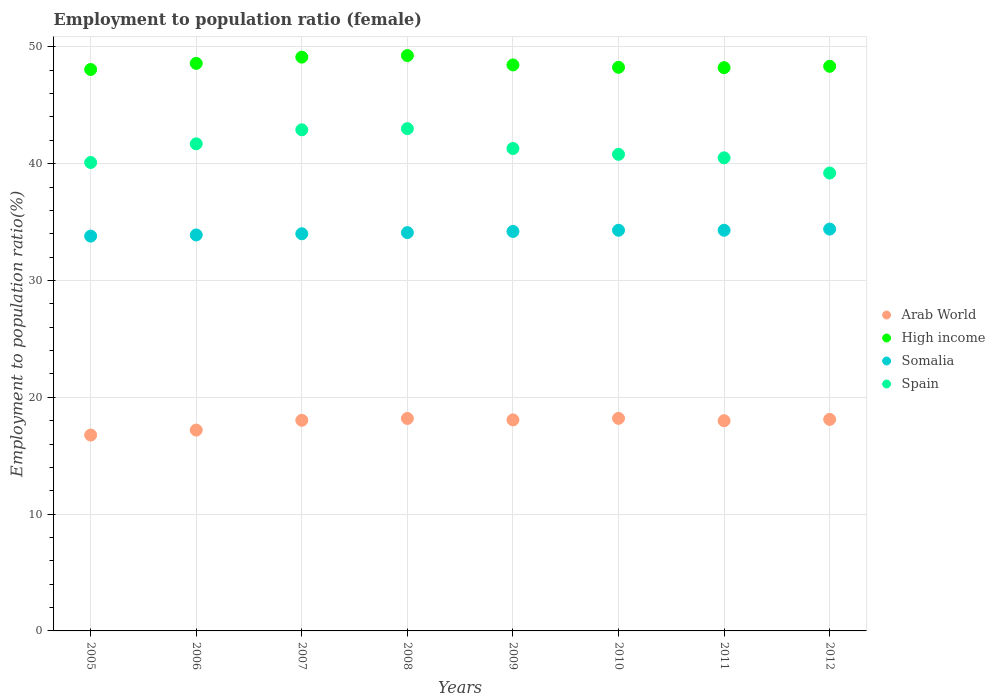How many different coloured dotlines are there?
Ensure brevity in your answer.  4. What is the employment to population ratio in Arab World in 2005?
Your response must be concise. 16.77. Across all years, what is the maximum employment to population ratio in Arab World?
Provide a short and direct response. 18.2. Across all years, what is the minimum employment to population ratio in Spain?
Your response must be concise. 39.2. What is the total employment to population ratio in Arab World in the graph?
Your response must be concise. 142.55. What is the difference between the employment to population ratio in High income in 2007 and that in 2012?
Your answer should be compact. 0.78. What is the difference between the employment to population ratio in High income in 2007 and the employment to population ratio in Arab World in 2008?
Your response must be concise. 30.93. What is the average employment to population ratio in Somalia per year?
Provide a short and direct response. 34.12. In the year 2012, what is the difference between the employment to population ratio in Arab World and employment to population ratio in High income?
Keep it short and to the point. -30.23. In how many years, is the employment to population ratio in Arab World greater than 8 %?
Keep it short and to the point. 8. What is the ratio of the employment to population ratio in Spain in 2006 to that in 2007?
Make the answer very short. 0.97. Is the employment to population ratio in Arab World in 2006 less than that in 2007?
Your answer should be compact. Yes. What is the difference between the highest and the second highest employment to population ratio in High income?
Provide a short and direct response. 0.14. What is the difference between the highest and the lowest employment to population ratio in Arab World?
Give a very brief answer. 1.43. Does the employment to population ratio in Spain monotonically increase over the years?
Keep it short and to the point. No. What is the difference between two consecutive major ticks on the Y-axis?
Your answer should be compact. 10. Are the values on the major ticks of Y-axis written in scientific E-notation?
Ensure brevity in your answer.  No. Does the graph contain any zero values?
Offer a very short reply. No. Does the graph contain grids?
Give a very brief answer. Yes. How are the legend labels stacked?
Provide a succinct answer. Vertical. What is the title of the graph?
Provide a succinct answer. Employment to population ratio (female). Does "Cameroon" appear as one of the legend labels in the graph?
Offer a very short reply. No. What is the label or title of the X-axis?
Your answer should be compact. Years. What is the label or title of the Y-axis?
Ensure brevity in your answer.  Employment to population ratio(%). What is the Employment to population ratio(%) in Arab World in 2005?
Your answer should be compact. 16.77. What is the Employment to population ratio(%) in High income in 2005?
Your answer should be compact. 48.06. What is the Employment to population ratio(%) in Somalia in 2005?
Provide a succinct answer. 33.8. What is the Employment to population ratio(%) of Spain in 2005?
Your answer should be compact. 40.1. What is the Employment to population ratio(%) of Arab World in 2006?
Make the answer very short. 17.19. What is the Employment to population ratio(%) in High income in 2006?
Keep it short and to the point. 48.59. What is the Employment to population ratio(%) of Somalia in 2006?
Provide a succinct answer. 33.9. What is the Employment to population ratio(%) of Spain in 2006?
Offer a terse response. 41.7. What is the Employment to population ratio(%) in Arab World in 2007?
Give a very brief answer. 18.03. What is the Employment to population ratio(%) of High income in 2007?
Your answer should be compact. 49.12. What is the Employment to population ratio(%) of Somalia in 2007?
Provide a short and direct response. 34. What is the Employment to population ratio(%) in Spain in 2007?
Offer a very short reply. 42.9. What is the Employment to population ratio(%) in Arab World in 2008?
Your response must be concise. 18.19. What is the Employment to population ratio(%) of High income in 2008?
Offer a terse response. 49.26. What is the Employment to population ratio(%) in Somalia in 2008?
Offer a terse response. 34.1. What is the Employment to population ratio(%) in Spain in 2008?
Provide a succinct answer. 43. What is the Employment to population ratio(%) of Arab World in 2009?
Provide a short and direct response. 18.07. What is the Employment to population ratio(%) in High income in 2009?
Your response must be concise. 48.46. What is the Employment to population ratio(%) of Somalia in 2009?
Keep it short and to the point. 34.2. What is the Employment to population ratio(%) of Spain in 2009?
Ensure brevity in your answer.  41.3. What is the Employment to population ratio(%) of Arab World in 2010?
Provide a short and direct response. 18.2. What is the Employment to population ratio(%) of High income in 2010?
Make the answer very short. 48.25. What is the Employment to population ratio(%) in Somalia in 2010?
Offer a terse response. 34.3. What is the Employment to population ratio(%) of Spain in 2010?
Offer a very short reply. 40.8. What is the Employment to population ratio(%) of Arab World in 2011?
Make the answer very short. 17.99. What is the Employment to population ratio(%) of High income in 2011?
Offer a very short reply. 48.22. What is the Employment to population ratio(%) in Somalia in 2011?
Your answer should be compact. 34.3. What is the Employment to population ratio(%) of Spain in 2011?
Offer a terse response. 40.5. What is the Employment to population ratio(%) of Arab World in 2012?
Offer a very short reply. 18.11. What is the Employment to population ratio(%) of High income in 2012?
Your answer should be very brief. 48.34. What is the Employment to population ratio(%) of Somalia in 2012?
Ensure brevity in your answer.  34.4. What is the Employment to population ratio(%) of Spain in 2012?
Make the answer very short. 39.2. Across all years, what is the maximum Employment to population ratio(%) of Arab World?
Give a very brief answer. 18.2. Across all years, what is the maximum Employment to population ratio(%) in High income?
Your answer should be very brief. 49.26. Across all years, what is the maximum Employment to population ratio(%) in Somalia?
Your response must be concise. 34.4. Across all years, what is the minimum Employment to population ratio(%) in Arab World?
Your response must be concise. 16.77. Across all years, what is the minimum Employment to population ratio(%) of High income?
Offer a very short reply. 48.06. Across all years, what is the minimum Employment to population ratio(%) of Somalia?
Provide a succinct answer. 33.8. Across all years, what is the minimum Employment to population ratio(%) in Spain?
Make the answer very short. 39.2. What is the total Employment to population ratio(%) of Arab World in the graph?
Offer a very short reply. 142.55. What is the total Employment to population ratio(%) of High income in the graph?
Provide a short and direct response. 388.29. What is the total Employment to population ratio(%) in Somalia in the graph?
Your answer should be compact. 273. What is the total Employment to population ratio(%) in Spain in the graph?
Your answer should be compact. 329.5. What is the difference between the Employment to population ratio(%) in Arab World in 2005 and that in 2006?
Offer a terse response. -0.43. What is the difference between the Employment to population ratio(%) of High income in 2005 and that in 2006?
Provide a succinct answer. -0.52. What is the difference between the Employment to population ratio(%) in Arab World in 2005 and that in 2007?
Your response must be concise. -1.26. What is the difference between the Employment to population ratio(%) in High income in 2005 and that in 2007?
Make the answer very short. -1.06. What is the difference between the Employment to population ratio(%) of Somalia in 2005 and that in 2007?
Ensure brevity in your answer.  -0.2. What is the difference between the Employment to population ratio(%) in Spain in 2005 and that in 2007?
Ensure brevity in your answer.  -2.8. What is the difference between the Employment to population ratio(%) in Arab World in 2005 and that in 2008?
Ensure brevity in your answer.  -1.42. What is the difference between the Employment to population ratio(%) of High income in 2005 and that in 2008?
Provide a short and direct response. -1.19. What is the difference between the Employment to population ratio(%) in Somalia in 2005 and that in 2008?
Offer a very short reply. -0.3. What is the difference between the Employment to population ratio(%) of Arab World in 2005 and that in 2009?
Offer a very short reply. -1.3. What is the difference between the Employment to population ratio(%) of High income in 2005 and that in 2009?
Make the answer very short. -0.39. What is the difference between the Employment to population ratio(%) in Spain in 2005 and that in 2009?
Make the answer very short. -1.2. What is the difference between the Employment to population ratio(%) of Arab World in 2005 and that in 2010?
Your response must be concise. -1.43. What is the difference between the Employment to population ratio(%) of High income in 2005 and that in 2010?
Keep it short and to the point. -0.19. What is the difference between the Employment to population ratio(%) in Arab World in 2005 and that in 2011?
Offer a very short reply. -1.23. What is the difference between the Employment to population ratio(%) in High income in 2005 and that in 2011?
Provide a short and direct response. -0.16. What is the difference between the Employment to population ratio(%) of Somalia in 2005 and that in 2011?
Ensure brevity in your answer.  -0.5. What is the difference between the Employment to population ratio(%) in Spain in 2005 and that in 2011?
Offer a very short reply. -0.4. What is the difference between the Employment to population ratio(%) in Arab World in 2005 and that in 2012?
Ensure brevity in your answer.  -1.34. What is the difference between the Employment to population ratio(%) in High income in 2005 and that in 2012?
Your answer should be compact. -0.27. What is the difference between the Employment to population ratio(%) of Somalia in 2005 and that in 2012?
Offer a terse response. -0.6. What is the difference between the Employment to population ratio(%) of Arab World in 2006 and that in 2007?
Give a very brief answer. -0.84. What is the difference between the Employment to population ratio(%) of High income in 2006 and that in 2007?
Provide a succinct answer. -0.54. What is the difference between the Employment to population ratio(%) in Somalia in 2006 and that in 2007?
Your answer should be compact. -0.1. What is the difference between the Employment to population ratio(%) in Spain in 2006 and that in 2007?
Keep it short and to the point. -1.2. What is the difference between the Employment to population ratio(%) of Arab World in 2006 and that in 2008?
Ensure brevity in your answer.  -1. What is the difference between the Employment to population ratio(%) of High income in 2006 and that in 2008?
Offer a very short reply. -0.67. What is the difference between the Employment to population ratio(%) in Spain in 2006 and that in 2008?
Keep it short and to the point. -1.3. What is the difference between the Employment to population ratio(%) in Arab World in 2006 and that in 2009?
Your answer should be compact. -0.87. What is the difference between the Employment to population ratio(%) in High income in 2006 and that in 2009?
Ensure brevity in your answer.  0.13. What is the difference between the Employment to population ratio(%) of Somalia in 2006 and that in 2009?
Provide a succinct answer. -0.3. What is the difference between the Employment to population ratio(%) in Arab World in 2006 and that in 2010?
Your answer should be very brief. -1. What is the difference between the Employment to population ratio(%) of High income in 2006 and that in 2010?
Offer a very short reply. 0.34. What is the difference between the Employment to population ratio(%) of Somalia in 2006 and that in 2010?
Your answer should be very brief. -0.4. What is the difference between the Employment to population ratio(%) of Arab World in 2006 and that in 2011?
Your answer should be compact. -0.8. What is the difference between the Employment to population ratio(%) in High income in 2006 and that in 2011?
Offer a very short reply. 0.37. What is the difference between the Employment to population ratio(%) in Somalia in 2006 and that in 2011?
Provide a succinct answer. -0.4. What is the difference between the Employment to population ratio(%) of Arab World in 2006 and that in 2012?
Give a very brief answer. -0.91. What is the difference between the Employment to population ratio(%) of High income in 2006 and that in 2012?
Provide a short and direct response. 0.25. What is the difference between the Employment to population ratio(%) of Somalia in 2006 and that in 2012?
Provide a short and direct response. -0.5. What is the difference between the Employment to population ratio(%) in Arab World in 2007 and that in 2008?
Your response must be concise. -0.16. What is the difference between the Employment to population ratio(%) of High income in 2007 and that in 2008?
Provide a succinct answer. -0.14. What is the difference between the Employment to population ratio(%) in Arab World in 2007 and that in 2009?
Offer a very short reply. -0.03. What is the difference between the Employment to population ratio(%) in High income in 2007 and that in 2009?
Give a very brief answer. 0.67. What is the difference between the Employment to population ratio(%) of Spain in 2007 and that in 2009?
Offer a terse response. 1.6. What is the difference between the Employment to population ratio(%) in Arab World in 2007 and that in 2010?
Your response must be concise. -0.17. What is the difference between the Employment to population ratio(%) in High income in 2007 and that in 2010?
Your response must be concise. 0.87. What is the difference between the Employment to population ratio(%) in Somalia in 2007 and that in 2010?
Your response must be concise. -0.3. What is the difference between the Employment to population ratio(%) of Arab World in 2007 and that in 2011?
Your response must be concise. 0.04. What is the difference between the Employment to population ratio(%) of High income in 2007 and that in 2011?
Your answer should be very brief. 0.9. What is the difference between the Employment to population ratio(%) of Somalia in 2007 and that in 2011?
Your answer should be very brief. -0.3. What is the difference between the Employment to population ratio(%) of Spain in 2007 and that in 2011?
Provide a succinct answer. 2.4. What is the difference between the Employment to population ratio(%) in Arab World in 2007 and that in 2012?
Your response must be concise. -0.08. What is the difference between the Employment to population ratio(%) in High income in 2007 and that in 2012?
Make the answer very short. 0.78. What is the difference between the Employment to population ratio(%) of Somalia in 2007 and that in 2012?
Keep it short and to the point. -0.4. What is the difference between the Employment to population ratio(%) in Spain in 2007 and that in 2012?
Provide a short and direct response. 3.7. What is the difference between the Employment to population ratio(%) in Arab World in 2008 and that in 2009?
Offer a very short reply. 0.12. What is the difference between the Employment to population ratio(%) of High income in 2008 and that in 2009?
Ensure brevity in your answer.  0.8. What is the difference between the Employment to population ratio(%) in Somalia in 2008 and that in 2009?
Give a very brief answer. -0.1. What is the difference between the Employment to population ratio(%) in Spain in 2008 and that in 2009?
Give a very brief answer. 1.7. What is the difference between the Employment to population ratio(%) of Arab World in 2008 and that in 2010?
Your response must be concise. -0.01. What is the difference between the Employment to population ratio(%) in Spain in 2008 and that in 2010?
Make the answer very short. 2.2. What is the difference between the Employment to population ratio(%) in Arab World in 2008 and that in 2011?
Offer a very short reply. 0.2. What is the difference between the Employment to population ratio(%) of High income in 2008 and that in 2011?
Your response must be concise. 1.04. What is the difference between the Employment to population ratio(%) of Arab World in 2008 and that in 2012?
Offer a very short reply. 0.08. What is the difference between the Employment to population ratio(%) of High income in 2008 and that in 2012?
Make the answer very short. 0.92. What is the difference between the Employment to population ratio(%) of Arab World in 2009 and that in 2010?
Ensure brevity in your answer.  -0.13. What is the difference between the Employment to population ratio(%) in High income in 2009 and that in 2010?
Provide a succinct answer. 0.2. What is the difference between the Employment to population ratio(%) in Spain in 2009 and that in 2010?
Your response must be concise. 0.5. What is the difference between the Employment to population ratio(%) of Arab World in 2009 and that in 2011?
Provide a short and direct response. 0.07. What is the difference between the Employment to population ratio(%) in High income in 2009 and that in 2011?
Your answer should be compact. 0.23. What is the difference between the Employment to population ratio(%) of Spain in 2009 and that in 2011?
Keep it short and to the point. 0.8. What is the difference between the Employment to population ratio(%) of Arab World in 2009 and that in 2012?
Offer a very short reply. -0.04. What is the difference between the Employment to population ratio(%) of High income in 2009 and that in 2012?
Provide a short and direct response. 0.12. What is the difference between the Employment to population ratio(%) in Somalia in 2009 and that in 2012?
Provide a succinct answer. -0.2. What is the difference between the Employment to population ratio(%) of Spain in 2009 and that in 2012?
Ensure brevity in your answer.  2.1. What is the difference between the Employment to population ratio(%) of Arab World in 2010 and that in 2011?
Provide a short and direct response. 0.2. What is the difference between the Employment to population ratio(%) of High income in 2010 and that in 2011?
Provide a short and direct response. 0.03. What is the difference between the Employment to population ratio(%) in Spain in 2010 and that in 2011?
Offer a terse response. 0.3. What is the difference between the Employment to population ratio(%) of Arab World in 2010 and that in 2012?
Your answer should be compact. 0.09. What is the difference between the Employment to population ratio(%) in High income in 2010 and that in 2012?
Ensure brevity in your answer.  -0.09. What is the difference between the Employment to population ratio(%) in Arab World in 2011 and that in 2012?
Your response must be concise. -0.11. What is the difference between the Employment to population ratio(%) in High income in 2011 and that in 2012?
Provide a short and direct response. -0.12. What is the difference between the Employment to population ratio(%) of Somalia in 2011 and that in 2012?
Give a very brief answer. -0.1. What is the difference between the Employment to population ratio(%) in Arab World in 2005 and the Employment to population ratio(%) in High income in 2006?
Give a very brief answer. -31.82. What is the difference between the Employment to population ratio(%) of Arab World in 2005 and the Employment to population ratio(%) of Somalia in 2006?
Offer a very short reply. -17.13. What is the difference between the Employment to population ratio(%) of Arab World in 2005 and the Employment to population ratio(%) of Spain in 2006?
Provide a short and direct response. -24.93. What is the difference between the Employment to population ratio(%) in High income in 2005 and the Employment to population ratio(%) in Somalia in 2006?
Give a very brief answer. 14.16. What is the difference between the Employment to population ratio(%) of High income in 2005 and the Employment to population ratio(%) of Spain in 2006?
Your answer should be compact. 6.36. What is the difference between the Employment to population ratio(%) in Somalia in 2005 and the Employment to population ratio(%) in Spain in 2006?
Your answer should be compact. -7.9. What is the difference between the Employment to population ratio(%) in Arab World in 2005 and the Employment to population ratio(%) in High income in 2007?
Your answer should be very brief. -32.35. What is the difference between the Employment to population ratio(%) of Arab World in 2005 and the Employment to population ratio(%) of Somalia in 2007?
Offer a terse response. -17.23. What is the difference between the Employment to population ratio(%) of Arab World in 2005 and the Employment to population ratio(%) of Spain in 2007?
Provide a succinct answer. -26.13. What is the difference between the Employment to population ratio(%) of High income in 2005 and the Employment to population ratio(%) of Somalia in 2007?
Provide a short and direct response. 14.06. What is the difference between the Employment to population ratio(%) of High income in 2005 and the Employment to population ratio(%) of Spain in 2007?
Ensure brevity in your answer.  5.16. What is the difference between the Employment to population ratio(%) in Somalia in 2005 and the Employment to population ratio(%) in Spain in 2007?
Your response must be concise. -9.1. What is the difference between the Employment to population ratio(%) in Arab World in 2005 and the Employment to population ratio(%) in High income in 2008?
Provide a short and direct response. -32.49. What is the difference between the Employment to population ratio(%) in Arab World in 2005 and the Employment to population ratio(%) in Somalia in 2008?
Keep it short and to the point. -17.33. What is the difference between the Employment to population ratio(%) in Arab World in 2005 and the Employment to population ratio(%) in Spain in 2008?
Your answer should be compact. -26.23. What is the difference between the Employment to population ratio(%) in High income in 2005 and the Employment to population ratio(%) in Somalia in 2008?
Give a very brief answer. 13.96. What is the difference between the Employment to population ratio(%) of High income in 2005 and the Employment to population ratio(%) of Spain in 2008?
Offer a terse response. 5.06. What is the difference between the Employment to population ratio(%) in Arab World in 2005 and the Employment to population ratio(%) in High income in 2009?
Provide a short and direct response. -31.69. What is the difference between the Employment to population ratio(%) in Arab World in 2005 and the Employment to population ratio(%) in Somalia in 2009?
Give a very brief answer. -17.43. What is the difference between the Employment to population ratio(%) in Arab World in 2005 and the Employment to population ratio(%) in Spain in 2009?
Ensure brevity in your answer.  -24.53. What is the difference between the Employment to population ratio(%) in High income in 2005 and the Employment to population ratio(%) in Somalia in 2009?
Provide a succinct answer. 13.86. What is the difference between the Employment to population ratio(%) in High income in 2005 and the Employment to population ratio(%) in Spain in 2009?
Your answer should be very brief. 6.76. What is the difference between the Employment to population ratio(%) in Somalia in 2005 and the Employment to population ratio(%) in Spain in 2009?
Offer a terse response. -7.5. What is the difference between the Employment to population ratio(%) in Arab World in 2005 and the Employment to population ratio(%) in High income in 2010?
Give a very brief answer. -31.48. What is the difference between the Employment to population ratio(%) of Arab World in 2005 and the Employment to population ratio(%) of Somalia in 2010?
Offer a terse response. -17.53. What is the difference between the Employment to population ratio(%) in Arab World in 2005 and the Employment to population ratio(%) in Spain in 2010?
Your answer should be compact. -24.03. What is the difference between the Employment to population ratio(%) of High income in 2005 and the Employment to population ratio(%) of Somalia in 2010?
Provide a succinct answer. 13.76. What is the difference between the Employment to population ratio(%) in High income in 2005 and the Employment to population ratio(%) in Spain in 2010?
Keep it short and to the point. 7.26. What is the difference between the Employment to population ratio(%) in Arab World in 2005 and the Employment to population ratio(%) in High income in 2011?
Provide a short and direct response. -31.45. What is the difference between the Employment to population ratio(%) of Arab World in 2005 and the Employment to population ratio(%) of Somalia in 2011?
Provide a succinct answer. -17.53. What is the difference between the Employment to population ratio(%) of Arab World in 2005 and the Employment to population ratio(%) of Spain in 2011?
Keep it short and to the point. -23.73. What is the difference between the Employment to population ratio(%) of High income in 2005 and the Employment to population ratio(%) of Somalia in 2011?
Your answer should be compact. 13.76. What is the difference between the Employment to population ratio(%) in High income in 2005 and the Employment to population ratio(%) in Spain in 2011?
Provide a succinct answer. 7.56. What is the difference between the Employment to population ratio(%) of Somalia in 2005 and the Employment to population ratio(%) of Spain in 2011?
Provide a short and direct response. -6.7. What is the difference between the Employment to population ratio(%) in Arab World in 2005 and the Employment to population ratio(%) in High income in 2012?
Offer a very short reply. -31.57. What is the difference between the Employment to population ratio(%) in Arab World in 2005 and the Employment to population ratio(%) in Somalia in 2012?
Offer a very short reply. -17.63. What is the difference between the Employment to population ratio(%) in Arab World in 2005 and the Employment to population ratio(%) in Spain in 2012?
Provide a short and direct response. -22.43. What is the difference between the Employment to population ratio(%) of High income in 2005 and the Employment to population ratio(%) of Somalia in 2012?
Give a very brief answer. 13.66. What is the difference between the Employment to population ratio(%) in High income in 2005 and the Employment to population ratio(%) in Spain in 2012?
Give a very brief answer. 8.86. What is the difference between the Employment to population ratio(%) of Somalia in 2005 and the Employment to population ratio(%) of Spain in 2012?
Your response must be concise. -5.4. What is the difference between the Employment to population ratio(%) in Arab World in 2006 and the Employment to population ratio(%) in High income in 2007?
Offer a very short reply. -31.93. What is the difference between the Employment to population ratio(%) in Arab World in 2006 and the Employment to population ratio(%) in Somalia in 2007?
Offer a very short reply. -16.81. What is the difference between the Employment to population ratio(%) in Arab World in 2006 and the Employment to population ratio(%) in Spain in 2007?
Your answer should be compact. -25.71. What is the difference between the Employment to population ratio(%) in High income in 2006 and the Employment to population ratio(%) in Somalia in 2007?
Ensure brevity in your answer.  14.59. What is the difference between the Employment to population ratio(%) in High income in 2006 and the Employment to population ratio(%) in Spain in 2007?
Offer a terse response. 5.69. What is the difference between the Employment to population ratio(%) in Somalia in 2006 and the Employment to population ratio(%) in Spain in 2007?
Provide a short and direct response. -9. What is the difference between the Employment to population ratio(%) in Arab World in 2006 and the Employment to population ratio(%) in High income in 2008?
Ensure brevity in your answer.  -32.06. What is the difference between the Employment to population ratio(%) in Arab World in 2006 and the Employment to population ratio(%) in Somalia in 2008?
Keep it short and to the point. -16.91. What is the difference between the Employment to population ratio(%) of Arab World in 2006 and the Employment to population ratio(%) of Spain in 2008?
Offer a very short reply. -25.81. What is the difference between the Employment to population ratio(%) in High income in 2006 and the Employment to population ratio(%) in Somalia in 2008?
Offer a very short reply. 14.49. What is the difference between the Employment to population ratio(%) in High income in 2006 and the Employment to population ratio(%) in Spain in 2008?
Keep it short and to the point. 5.59. What is the difference between the Employment to population ratio(%) of Arab World in 2006 and the Employment to population ratio(%) of High income in 2009?
Your answer should be compact. -31.26. What is the difference between the Employment to population ratio(%) of Arab World in 2006 and the Employment to population ratio(%) of Somalia in 2009?
Offer a terse response. -17.01. What is the difference between the Employment to population ratio(%) in Arab World in 2006 and the Employment to population ratio(%) in Spain in 2009?
Ensure brevity in your answer.  -24.11. What is the difference between the Employment to population ratio(%) in High income in 2006 and the Employment to population ratio(%) in Somalia in 2009?
Offer a terse response. 14.39. What is the difference between the Employment to population ratio(%) of High income in 2006 and the Employment to population ratio(%) of Spain in 2009?
Your response must be concise. 7.29. What is the difference between the Employment to population ratio(%) of Somalia in 2006 and the Employment to population ratio(%) of Spain in 2009?
Offer a very short reply. -7.4. What is the difference between the Employment to population ratio(%) of Arab World in 2006 and the Employment to population ratio(%) of High income in 2010?
Your answer should be compact. -31.06. What is the difference between the Employment to population ratio(%) in Arab World in 2006 and the Employment to population ratio(%) in Somalia in 2010?
Keep it short and to the point. -17.11. What is the difference between the Employment to population ratio(%) in Arab World in 2006 and the Employment to population ratio(%) in Spain in 2010?
Ensure brevity in your answer.  -23.61. What is the difference between the Employment to population ratio(%) of High income in 2006 and the Employment to population ratio(%) of Somalia in 2010?
Give a very brief answer. 14.29. What is the difference between the Employment to population ratio(%) in High income in 2006 and the Employment to population ratio(%) in Spain in 2010?
Offer a very short reply. 7.79. What is the difference between the Employment to population ratio(%) of Somalia in 2006 and the Employment to population ratio(%) of Spain in 2010?
Ensure brevity in your answer.  -6.9. What is the difference between the Employment to population ratio(%) in Arab World in 2006 and the Employment to population ratio(%) in High income in 2011?
Your answer should be very brief. -31.03. What is the difference between the Employment to population ratio(%) in Arab World in 2006 and the Employment to population ratio(%) in Somalia in 2011?
Provide a short and direct response. -17.11. What is the difference between the Employment to population ratio(%) in Arab World in 2006 and the Employment to population ratio(%) in Spain in 2011?
Provide a succinct answer. -23.31. What is the difference between the Employment to population ratio(%) of High income in 2006 and the Employment to population ratio(%) of Somalia in 2011?
Give a very brief answer. 14.29. What is the difference between the Employment to population ratio(%) of High income in 2006 and the Employment to population ratio(%) of Spain in 2011?
Provide a succinct answer. 8.09. What is the difference between the Employment to population ratio(%) of Somalia in 2006 and the Employment to population ratio(%) of Spain in 2011?
Give a very brief answer. -6.6. What is the difference between the Employment to population ratio(%) of Arab World in 2006 and the Employment to population ratio(%) of High income in 2012?
Ensure brevity in your answer.  -31.14. What is the difference between the Employment to population ratio(%) of Arab World in 2006 and the Employment to population ratio(%) of Somalia in 2012?
Give a very brief answer. -17.21. What is the difference between the Employment to population ratio(%) of Arab World in 2006 and the Employment to population ratio(%) of Spain in 2012?
Ensure brevity in your answer.  -22.01. What is the difference between the Employment to population ratio(%) in High income in 2006 and the Employment to population ratio(%) in Somalia in 2012?
Keep it short and to the point. 14.19. What is the difference between the Employment to population ratio(%) of High income in 2006 and the Employment to population ratio(%) of Spain in 2012?
Make the answer very short. 9.39. What is the difference between the Employment to population ratio(%) of Somalia in 2006 and the Employment to population ratio(%) of Spain in 2012?
Offer a terse response. -5.3. What is the difference between the Employment to population ratio(%) of Arab World in 2007 and the Employment to population ratio(%) of High income in 2008?
Provide a succinct answer. -31.23. What is the difference between the Employment to population ratio(%) of Arab World in 2007 and the Employment to population ratio(%) of Somalia in 2008?
Offer a very short reply. -16.07. What is the difference between the Employment to population ratio(%) of Arab World in 2007 and the Employment to population ratio(%) of Spain in 2008?
Provide a succinct answer. -24.97. What is the difference between the Employment to population ratio(%) of High income in 2007 and the Employment to population ratio(%) of Somalia in 2008?
Keep it short and to the point. 15.02. What is the difference between the Employment to population ratio(%) in High income in 2007 and the Employment to population ratio(%) in Spain in 2008?
Make the answer very short. 6.12. What is the difference between the Employment to population ratio(%) in Arab World in 2007 and the Employment to population ratio(%) in High income in 2009?
Your response must be concise. -30.42. What is the difference between the Employment to population ratio(%) of Arab World in 2007 and the Employment to population ratio(%) of Somalia in 2009?
Your answer should be compact. -16.17. What is the difference between the Employment to population ratio(%) in Arab World in 2007 and the Employment to population ratio(%) in Spain in 2009?
Your response must be concise. -23.27. What is the difference between the Employment to population ratio(%) of High income in 2007 and the Employment to population ratio(%) of Somalia in 2009?
Your answer should be very brief. 14.92. What is the difference between the Employment to population ratio(%) of High income in 2007 and the Employment to population ratio(%) of Spain in 2009?
Your response must be concise. 7.82. What is the difference between the Employment to population ratio(%) in Arab World in 2007 and the Employment to population ratio(%) in High income in 2010?
Ensure brevity in your answer.  -30.22. What is the difference between the Employment to population ratio(%) in Arab World in 2007 and the Employment to population ratio(%) in Somalia in 2010?
Your answer should be compact. -16.27. What is the difference between the Employment to population ratio(%) in Arab World in 2007 and the Employment to population ratio(%) in Spain in 2010?
Your response must be concise. -22.77. What is the difference between the Employment to population ratio(%) in High income in 2007 and the Employment to population ratio(%) in Somalia in 2010?
Your response must be concise. 14.82. What is the difference between the Employment to population ratio(%) in High income in 2007 and the Employment to population ratio(%) in Spain in 2010?
Give a very brief answer. 8.32. What is the difference between the Employment to population ratio(%) of Arab World in 2007 and the Employment to population ratio(%) of High income in 2011?
Your response must be concise. -30.19. What is the difference between the Employment to population ratio(%) of Arab World in 2007 and the Employment to population ratio(%) of Somalia in 2011?
Give a very brief answer. -16.27. What is the difference between the Employment to population ratio(%) of Arab World in 2007 and the Employment to population ratio(%) of Spain in 2011?
Provide a succinct answer. -22.47. What is the difference between the Employment to population ratio(%) of High income in 2007 and the Employment to population ratio(%) of Somalia in 2011?
Offer a very short reply. 14.82. What is the difference between the Employment to population ratio(%) of High income in 2007 and the Employment to population ratio(%) of Spain in 2011?
Offer a terse response. 8.62. What is the difference between the Employment to population ratio(%) of Arab World in 2007 and the Employment to population ratio(%) of High income in 2012?
Provide a succinct answer. -30.31. What is the difference between the Employment to population ratio(%) of Arab World in 2007 and the Employment to population ratio(%) of Somalia in 2012?
Offer a very short reply. -16.37. What is the difference between the Employment to population ratio(%) in Arab World in 2007 and the Employment to population ratio(%) in Spain in 2012?
Ensure brevity in your answer.  -21.17. What is the difference between the Employment to population ratio(%) in High income in 2007 and the Employment to population ratio(%) in Somalia in 2012?
Make the answer very short. 14.72. What is the difference between the Employment to population ratio(%) in High income in 2007 and the Employment to population ratio(%) in Spain in 2012?
Keep it short and to the point. 9.92. What is the difference between the Employment to population ratio(%) in Somalia in 2007 and the Employment to population ratio(%) in Spain in 2012?
Your answer should be compact. -5.2. What is the difference between the Employment to population ratio(%) in Arab World in 2008 and the Employment to population ratio(%) in High income in 2009?
Your answer should be very brief. -30.27. What is the difference between the Employment to population ratio(%) of Arab World in 2008 and the Employment to population ratio(%) of Somalia in 2009?
Provide a succinct answer. -16.01. What is the difference between the Employment to population ratio(%) in Arab World in 2008 and the Employment to population ratio(%) in Spain in 2009?
Your answer should be very brief. -23.11. What is the difference between the Employment to population ratio(%) in High income in 2008 and the Employment to population ratio(%) in Somalia in 2009?
Offer a very short reply. 15.06. What is the difference between the Employment to population ratio(%) in High income in 2008 and the Employment to population ratio(%) in Spain in 2009?
Give a very brief answer. 7.96. What is the difference between the Employment to population ratio(%) in Somalia in 2008 and the Employment to population ratio(%) in Spain in 2009?
Ensure brevity in your answer.  -7.2. What is the difference between the Employment to population ratio(%) of Arab World in 2008 and the Employment to population ratio(%) of High income in 2010?
Offer a terse response. -30.06. What is the difference between the Employment to population ratio(%) in Arab World in 2008 and the Employment to population ratio(%) in Somalia in 2010?
Your answer should be very brief. -16.11. What is the difference between the Employment to population ratio(%) of Arab World in 2008 and the Employment to population ratio(%) of Spain in 2010?
Your answer should be very brief. -22.61. What is the difference between the Employment to population ratio(%) in High income in 2008 and the Employment to population ratio(%) in Somalia in 2010?
Keep it short and to the point. 14.96. What is the difference between the Employment to population ratio(%) of High income in 2008 and the Employment to population ratio(%) of Spain in 2010?
Ensure brevity in your answer.  8.46. What is the difference between the Employment to population ratio(%) of Somalia in 2008 and the Employment to population ratio(%) of Spain in 2010?
Give a very brief answer. -6.7. What is the difference between the Employment to population ratio(%) of Arab World in 2008 and the Employment to population ratio(%) of High income in 2011?
Offer a terse response. -30.03. What is the difference between the Employment to population ratio(%) in Arab World in 2008 and the Employment to population ratio(%) in Somalia in 2011?
Provide a short and direct response. -16.11. What is the difference between the Employment to population ratio(%) of Arab World in 2008 and the Employment to population ratio(%) of Spain in 2011?
Make the answer very short. -22.31. What is the difference between the Employment to population ratio(%) of High income in 2008 and the Employment to population ratio(%) of Somalia in 2011?
Offer a terse response. 14.96. What is the difference between the Employment to population ratio(%) in High income in 2008 and the Employment to population ratio(%) in Spain in 2011?
Your answer should be compact. 8.76. What is the difference between the Employment to population ratio(%) of Arab World in 2008 and the Employment to population ratio(%) of High income in 2012?
Provide a short and direct response. -30.15. What is the difference between the Employment to population ratio(%) of Arab World in 2008 and the Employment to population ratio(%) of Somalia in 2012?
Your answer should be compact. -16.21. What is the difference between the Employment to population ratio(%) of Arab World in 2008 and the Employment to population ratio(%) of Spain in 2012?
Offer a very short reply. -21.01. What is the difference between the Employment to population ratio(%) of High income in 2008 and the Employment to population ratio(%) of Somalia in 2012?
Your response must be concise. 14.86. What is the difference between the Employment to population ratio(%) of High income in 2008 and the Employment to population ratio(%) of Spain in 2012?
Provide a succinct answer. 10.06. What is the difference between the Employment to population ratio(%) of Somalia in 2008 and the Employment to population ratio(%) of Spain in 2012?
Your answer should be compact. -5.1. What is the difference between the Employment to population ratio(%) in Arab World in 2009 and the Employment to population ratio(%) in High income in 2010?
Offer a terse response. -30.18. What is the difference between the Employment to population ratio(%) of Arab World in 2009 and the Employment to population ratio(%) of Somalia in 2010?
Provide a succinct answer. -16.23. What is the difference between the Employment to population ratio(%) in Arab World in 2009 and the Employment to population ratio(%) in Spain in 2010?
Offer a terse response. -22.73. What is the difference between the Employment to population ratio(%) of High income in 2009 and the Employment to population ratio(%) of Somalia in 2010?
Provide a short and direct response. 14.16. What is the difference between the Employment to population ratio(%) of High income in 2009 and the Employment to population ratio(%) of Spain in 2010?
Ensure brevity in your answer.  7.66. What is the difference between the Employment to population ratio(%) in Somalia in 2009 and the Employment to population ratio(%) in Spain in 2010?
Ensure brevity in your answer.  -6.6. What is the difference between the Employment to population ratio(%) of Arab World in 2009 and the Employment to population ratio(%) of High income in 2011?
Offer a terse response. -30.16. What is the difference between the Employment to population ratio(%) of Arab World in 2009 and the Employment to population ratio(%) of Somalia in 2011?
Offer a very short reply. -16.23. What is the difference between the Employment to population ratio(%) in Arab World in 2009 and the Employment to population ratio(%) in Spain in 2011?
Keep it short and to the point. -22.43. What is the difference between the Employment to population ratio(%) in High income in 2009 and the Employment to population ratio(%) in Somalia in 2011?
Provide a short and direct response. 14.16. What is the difference between the Employment to population ratio(%) of High income in 2009 and the Employment to population ratio(%) of Spain in 2011?
Offer a very short reply. 7.96. What is the difference between the Employment to population ratio(%) of Somalia in 2009 and the Employment to population ratio(%) of Spain in 2011?
Offer a terse response. -6.3. What is the difference between the Employment to population ratio(%) of Arab World in 2009 and the Employment to population ratio(%) of High income in 2012?
Your answer should be compact. -30.27. What is the difference between the Employment to population ratio(%) of Arab World in 2009 and the Employment to population ratio(%) of Somalia in 2012?
Keep it short and to the point. -16.33. What is the difference between the Employment to population ratio(%) of Arab World in 2009 and the Employment to population ratio(%) of Spain in 2012?
Provide a short and direct response. -21.13. What is the difference between the Employment to population ratio(%) in High income in 2009 and the Employment to population ratio(%) in Somalia in 2012?
Offer a terse response. 14.06. What is the difference between the Employment to population ratio(%) in High income in 2009 and the Employment to population ratio(%) in Spain in 2012?
Ensure brevity in your answer.  9.26. What is the difference between the Employment to population ratio(%) of Somalia in 2009 and the Employment to population ratio(%) of Spain in 2012?
Ensure brevity in your answer.  -5. What is the difference between the Employment to population ratio(%) of Arab World in 2010 and the Employment to population ratio(%) of High income in 2011?
Offer a very short reply. -30.02. What is the difference between the Employment to population ratio(%) in Arab World in 2010 and the Employment to population ratio(%) in Somalia in 2011?
Offer a very short reply. -16.1. What is the difference between the Employment to population ratio(%) of Arab World in 2010 and the Employment to population ratio(%) of Spain in 2011?
Offer a terse response. -22.3. What is the difference between the Employment to population ratio(%) in High income in 2010 and the Employment to population ratio(%) in Somalia in 2011?
Keep it short and to the point. 13.95. What is the difference between the Employment to population ratio(%) in High income in 2010 and the Employment to population ratio(%) in Spain in 2011?
Provide a succinct answer. 7.75. What is the difference between the Employment to population ratio(%) of Somalia in 2010 and the Employment to population ratio(%) of Spain in 2011?
Your answer should be very brief. -6.2. What is the difference between the Employment to population ratio(%) in Arab World in 2010 and the Employment to population ratio(%) in High income in 2012?
Your response must be concise. -30.14. What is the difference between the Employment to population ratio(%) of Arab World in 2010 and the Employment to population ratio(%) of Somalia in 2012?
Give a very brief answer. -16.2. What is the difference between the Employment to population ratio(%) in Arab World in 2010 and the Employment to population ratio(%) in Spain in 2012?
Provide a succinct answer. -21. What is the difference between the Employment to population ratio(%) of High income in 2010 and the Employment to population ratio(%) of Somalia in 2012?
Offer a terse response. 13.85. What is the difference between the Employment to population ratio(%) in High income in 2010 and the Employment to population ratio(%) in Spain in 2012?
Your response must be concise. 9.05. What is the difference between the Employment to population ratio(%) in Arab World in 2011 and the Employment to population ratio(%) in High income in 2012?
Offer a terse response. -30.34. What is the difference between the Employment to population ratio(%) of Arab World in 2011 and the Employment to population ratio(%) of Somalia in 2012?
Provide a short and direct response. -16.41. What is the difference between the Employment to population ratio(%) of Arab World in 2011 and the Employment to population ratio(%) of Spain in 2012?
Make the answer very short. -21.21. What is the difference between the Employment to population ratio(%) in High income in 2011 and the Employment to population ratio(%) in Somalia in 2012?
Provide a succinct answer. 13.82. What is the difference between the Employment to population ratio(%) in High income in 2011 and the Employment to population ratio(%) in Spain in 2012?
Provide a short and direct response. 9.02. What is the difference between the Employment to population ratio(%) of Somalia in 2011 and the Employment to population ratio(%) of Spain in 2012?
Your response must be concise. -4.9. What is the average Employment to population ratio(%) of Arab World per year?
Make the answer very short. 17.82. What is the average Employment to population ratio(%) in High income per year?
Give a very brief answer. 48.54. What is the average Employment to population ratio(%) in Somalia per year?
Offer a very short reply. 34.12. What is the average Employment to population ratio(%) in Spain per year?
Ensure brevity in your answer.  41.19. In the year 2005, what is the difference between the Employment to population ratio(%) in Arab World and Employment to population ratio(%) in High income?
Make the answer very short. -31.3. In the year 2005, what is the difference between the Employment to population ratio(%) of Arab World and Employment to population ratio(%) of Somalia?
Offer a terse response. -17.03. In the year 2005, what is the difference between the Employment to population ratio(%) of Arab World and Employment to population ratio(%) of Spain?
Ensure brevity in your answer.  -23.33. In the year 2005, what is the difference between the Employment to population ratio(%) of High income and Employment to population ratio(%) of Somalia?
Ensure brevity in your answer.  14.26. In the year 2005, what is the difference between the Employment to population ratio(%) of High income and Employment to population ratio(%) of Spain?
Your response must be concise. 7.96. In the year 2006, what is the difference between the Employment to population ratio(%) of Arab World and Employment to population ratio(%) of High income?
Your answer should be very brief. -31.39. In the year 2006, what is the difference between the Employment to population ratio(%) in Arab World and Employment to population ratio(%) in Somalia?
Ensure brevity in your answer.  -16.71. In the year 2006, what is the difference between the Employment to population ratio(%) in Arab World and Employment to population ratio(%) in Spain?
Make the answer very short. -24.51. In the year 2006, what is the difference between the Employment to population ratio(%) in High income and Employment to population ratio(%) in Somalia?
Offer a very short reply. 14.69. In the year 2006, what is the difference between the Employment to population ratio(%) of High income and Employment to population ratio(%) of Spain?
Give a very brief answer. 6.89. In the year 2006, what is the difference between the Employment to population ratio(%) of Somalia and Employment to population ratio(%) of Spain?
Offer a very short reply. -7.8. In the year 2007, what is the difference between the Employment to population ratio(%) in Arab World and Employment to population ratio(%) in High income?
Your answer should be very brief. -31.09. In the year 2007, what is the difference between the Employment to population ratio(%) of Arab World and Employment to population ratio(%) of Somalia?
Provide a succinct answer. -15.97. In the year 2007, what is the difference between the Employment to population ratio(%) of Arab World and Employment to population ratio(%) of Spain?
Give a very brief answer. -24.87. In the year 2007, what is the difference between the Employment to population ratio(%) of High income and Employment to population ratio(%) of Somalia?
Your answer should be very brief. 15.12. In the year 2007, what is the difference between the Employment to population ratio(%) in High income and Employment to population ratio(%) in Spain?
Provide a short and direct response. 6.22. In the year 2008, what is the difference between the Employment to population ratio(%) in Arab World and Employment to population ratio(%) in High income?
Give a very brief answer. -31.07. In the year 2008, what is the difference between the Employment to population ratio(%) of Arab World and Employment to population ratio(%) of Somalia?
Your response must be concise. -15.91. In the year 2008, what is the difference between the Employment to population ratio(%) in Arab World and Employment to population ratio(%) in Spain?
Ensure brevity in your answer.  -24.81. In the year 2008, what is the difference between the Employment to population ratio(%) of High income and Employment to population ratio(%) of Somalia?
Give a very brief answer. 15.16. In the year 2008, what is the difference between the Employment to population ratio(%) in High income and Employment to population ratio(%) in Spain?
Give a very brief answer. 6.26. In the year 2009, what is the difference between the Employment to population ratio(%) of Arab World and Employment to population ratio(%) of High income?
Keep it short and to the point. -30.39. In the year 2009, what is the difference between the Employment to population ratio(%) of Arab World and Employment to population ratio(%) of Somalia?
Provide a succinct answer. -16.13. In the year 2009, what is the difference between the Employment to population ratio(%) in Arab World and Employment to population ratio(%) in Spain?
Offer a terse response. -23.23. In the year 2009, what is the difference between the Employment to population ratio(%) in High income and Employment to population ratio(%) in Somalia?
Provide a succinct answer. 14.26. In the year 2009, what is the difference between the Employment to population ratio(%) in High income and Employment to population ratio(%) in Spain?
Offer a terse response. 7.16. In the year 2010, what is the difference between the Employment to population ratio(%) of Arab World and Employment to population ratio(%) of High income?
Offer a terse response. -30.05. In the year 2010, what is the difference between the Employment to population ratio(%) of Arab World and Employment to population ratio(%) of Somalia?
Your answer should be compact. -16.1. In the year 2010, what is the difference between the Employment to population ratio(%) of Arab World and Employment to population ratio(%) of Spain?
Give a very brief answer. -22.6. In the year 2010, what is the difference between the Employment to population ratio(%) in High income and Employment to population ratio(%) in Somalia?
Ensure brevity in your answer.  13.95. In the year 2010, what is the difference between the Employment to population ratio(%) of High income and Employment to population ratio(%) of Spain?
Provide a succinct answer. 7.45. In the year 2011, what is the difference between the Employment to population ratio(%) in Arab World and Employment to population ratio(%) in High income?
Provide a short and direct response. -30.23. In the year 2011, what is the difference between the Employment to population ratio(%) in Arab World and Employment to population ratio(%) in Somalia?
Provide a succinct answer. -16.31. In the year 2011, what is the difference between the Employment to population ratio(%) of Arab World and Employment to population ratio(%) of Spain?
Provide a short and direct response. -22.51. In the year 2011, what is the difference between the Employment to population ratio(%) in High income and Employment to population ratio(%) in Somalia?
Offer a very short reply. 13.92. In the year 2011, what is the difference between the Employment to population ratio(%) in High income and Employment to population ratio(%) in Spain?
Your answer should be very brief. 7.72. In the year 2011, what is the difference between the Employment to population ratio(%) of Somalia and Employment to population ratio(%) of Spain?
Your answer should be compact. -6.2. In the year 2012, what is the difference between the Employment to population ratio(%) in Arab World and Employment to population ratio(%) in High income?
Your answer should be very brief. -30.23. In the year 2012, what is the difference between the Employment to population ratio(%) in Arab World and Employment to population ratio(%) in Somalia?
Offer a very short reply. -16.29. In the year 2012, what is the difference between the Employment to population ratio(%) in Arab World and Employment to population ratio(%) in Spain?
Ensure brevity in your answer.  -21.09. In the year 2012, what is the difference between the Employment to population ratio(%) of High income and Employment to population ratio(%) of Somalia?
Your answer should be compact. 13.94. In the year 2012, what is the difference between the Employment to population ratio(%) of High income and Employment to population ratio(%) of Spain?
Your response must be concise. 9.14. What is the ratio of the Employment to population ratio(%) in Arab World in 2005 to that in 2006?
Give a very brief answer. 0.98. What is the ratio of the Employment to population ratio(%) in High income in 2005 to that in 2006?
Provide a short and direct response. 0.99. What is the ratio of the Employment to population ratio(%) of Spain in 2005 to that in 2006?
Provide a short and direct response. 0.96. What is the ratio of the Employment to population ratio(%) in Arab World in 2005 to that in 2007?
Offer a terse response. 0.93. What is the ratio of the Employment to population ratio(%) in High income in 2005 to that in 2007?
Offer a very short reply. 0.98. What is the ratio of the Employment to population ratio(%) of Spain in 2005 to that in 2007?
Provide a succinct answer. 0.93. What is the ratio of the Employment to population ratio(%) in Arab World in 2005 to that in 2008?
Offer a terse response. 0.92. What is the ratio of the Employment to population ratio(%) of High income in 2005 to that in 2008?
Give a very brief answer. 0.98. What is the ratio of the Employment to population ratio(%) of Spain in 2005 to that in 2008?
Give a very brief answer. 0.93. What is the ratio of the Employment to population ratio(%) of Arab World in 2005 to that in 2009?
Provide a short and direct response. 0.93. What is the ratio of the Employment to population ratio(%) in High income in 2005 to that in 2009?
Make the answer very short. 0.99. What is the ratio of the Employment to population ratio(%) in Somalia in 2005 to that in 2009?
Offer a very short reply. 0.99. What is the ratio of the Employment to population ratio(%) of Spain in 2005 to that in 2009?
Give a very brief answer. 0.97. What is the ratio of the Employment to population ratio(%) of Arab World in 2005 to that in 2010?
Offer a very short reply. 0.92. What is the ratio of the Employment to population ratio(%) in High income in 2005 to that in 2010?
Your response must be concise. 1. What is the ratio of the Employment to population ratio(%) in Somalia in 2005 to that in 2010?
Your response must be concise. 0.99. What is the ratio of the Employment to population ratio(%) in Spain in 2005 to that in 2010?
Ensure brevity in your answer.  0.98. What is the ratio of the Employment to population ratio(%) in Arab World in 2005 to that in 2011?
Provide a succinct answer. 0.93. What is the ratio of the Employment to population ratio(%) in High income in 2005 to that in 2011?
Your answer should be very brief. 1. What is the ratio of the Employment to population ratio(%) in Somalia in 2005 to that in 2011?
Your answer should be compact. 0.99. What is the ratio of the Employment to population ratio(%) of Arab World in 2005 to that in 2012?
Offer a terse response. 0.93. What is the ratio of the Employment to population ratio(%) of High income in 2005 to that in 2012?
Offer a very short reply. 0.99. What is the ratio of the Employment to population ratio(%) in Somalia in 2005 to that in 2012?
Offer a terse response. 0.98. What is the ratio of the Employment to population ratio(%) in Spain in 2005 to that in 2012?
Your response must be concise. 1.02. What is the ratio of the Employment to population ratio(%) of Arab World in 2006 to that in 2007?
Give a very brief answer. 0.95. What is the ratio of the Employment to population ratio(%) of High income in 2006 to that in 2007?
Offer a very short reply. 0.99. What is the ratio of the Employment to population ratio(%) of Spain in 2006 to that in 2007?
Your answer should be compact. 0.97. What is the ratio of the Employment to population ratio(%) of Arab World in 2006 to that in 2008?
Keep it short and to the point. 0.95. What is the ratio of the Employment to population ratio(%) of High income in 2006 to that in 2008?
Provide a short and direct response. 0.99. What is the ratio of the Employment to population ratio(%) in Somalia in 2006 to that in 2008?
Make the answer very short. 0.99. What is the ratio of the Employment to population ratio(%) in Spain in 2006 to that in 2008?
Your answer should be compact. 0.97. What is the ratio of the Employment to population ratio(%) of Arab World in 2006 to that in 2009?
Ensure brevity in your answer.  0.95. What is the ratio of the Employment to population ratio(%) of High income in 2006 to that in 2009?
Your response must be concise. 1. What is the ratio of the Employment to population ratio(%) in Somalia in 2006 to that in 2009?
Keep it short and to the point. 0.99. What is the ratio of the Employment to population ratio(%) of Spain in 2006 to that in 2009?
Your response must be concise. 1.01. What is the ratio of the Employment to population ratio(%) of Arab World in 2006 to that in 2010?
Your response must be concise. 0.94. What is the ratio of the Employment to population ratio(%) in Somalia in 2006 to that in 2010?
Your answer should be very brief. 0.99. What is the ratio of the Employment to population ratio(%) in Spain in 2006 to that in 2010?
Give a very brief answer. 1.02. What is the ratio of the Employment to population ratio(%) of Arab World in 2006 to that in 2011?
Give a very brief answer. 0.96. What is the ratio of the Employment to population ratio(%) of High income in 2006 to that in 2011?
Give a very brief answer. 1.01. What is the ratio of the Employment to population ratio(%) in Somalia in 2006 to that in 2011?
Your response must be concise. 0.99. What is the ratio of the Employment to population ratio(%) of Spain in 2006 to that in 2011?
Offer a very short reply. 1.03. What is the ratio of the Employment to population ratio(%) in Arab World in 2006 to that in 2012?
Ensure brevity in your answer.  0.95. What is the ratio of the Employment to population ratio(%) in Somalia in 2006 to that in 2012?
Provide a short and direct response. 0.99. What is the ratio of the Employment to population ratio(%) of Spain in 2006 to that in 2012?
Provide a short and direct response. 1.06. What is the ratio of the Employment to population ratio(%) of High income in 2007 to that in 2008?
Your answer should be compact. 1. What is the ratio of the Employment to population ratio(%) in Somalia in 2007 to that in 2008?
Your answer should be compact. 1. What is the ratio of the Employment to population ratio(%) in High income in 2007 to that in 2009?
Give a very brief answer. 1.01. What is the ratio of the Employment to population ratio(%) of Spain in 2007 to that in 2009?
Keep it short and to the point. 1.04. What is the ratio of the Employment to population ratio(%) of Arab World in 2007 to that in 2010?
Give a very brief answer. 0.99. What is the ratio of the Employment to population ratio(%) in High income in 2007 to that in 2010?
Provide a succinct answer. 1.02. What is the ratio of the Employment to population ratio(%) of Spain in 2007 to that in 2010?
Ensure brevity in your answer.  1.05. What is the ratio of the Employment to population ratio(%) of High income in 2007 to that in 2011?
Your answer should be very brief. 1.02. What is the ratio of the Employment to population ratio(%) of Spain in 2007 to that in 2011?
Your answer should be compact. 1.06. What is the ratio of the Employment to population ratio(%) in Arab World in 2007 to that in 2012?
Give a very brief answer. 1. What is the ratio of the Employment to population ratio(%) in High income in 2007 to that in 2012?
Your answer should be very brief. 1.02. What is the ratio of the Employment to population ratio(%) of Somalia in 2007 to that in 2012?
Keep it short and to the point. 0.99. What is the ratio of the Employment to population ratio(%) of Spain in 2007 to that in 2012?
Your answer should be very brief. 1.09. What is the ratio of the Employment to population ratio(%) of Arab World in 2008 to that in 2009?
Keep it short and to the point. 1.01. What is the ratio of the Employment to population ratio(%) of High income in 2008 to that in 2009?
Your answer should be compact. 1.02. What is the ratio of the Employment to population ratio(%) in Spain in 2008 to that in 2009?
Offer a terse response. 1.04. What is the ratio of the Employment to population ratio(%) in High income in 2008 to that in 2010?
Your response must be concise. 1.02. What is the ratio of the Employment to population ratio(%) in Somalia in 2008 to that in 2010?
Ensure brevity in your answer.  0.99. What is the ratio of the Employment to population ratio(%) in Spain in 2008 to that in 2010?
Your response must be concise. 1.05. What is the ratio of the Employment to population ratio(%) of Arab World in 2008 to that in 2011?
Offer a terse response. 1.01. What is the ratio of the Employment to population ratio(%) of High income in 2008 to that in 2011?
Ensure brevity in your answer.  1.02. What is the ratio of the Employment to population ratio(%) of Spain in 2008 to that in 2011?
Ensure brevity in your answer.  1.06. What is the ratio of the Employment to population ratio(%) in Somalia in 2008 to that in 2012?
Give a very brief answer. 0.99. What is the ratio of the Employment to population ratio(%) in Spain in 2008 to that in 2012?
Your response must be concise. 1.1. What is the ratio of the Employment to population ratio(%) of Arab World in 2009 to that in 2010?
Offer a terse response. 0.99. What is the ratio of the Employment to population ratio(%) of High income in 2009 to that in 2010?
Make the answer very short. 1. What is the ratio of the Employment to population ratio(%) in Spain in 2009 to that in 2010?
Provide a succinct answer. 1.01. What is the ratio of the Employment to population ratio(%) in Spain in 2009 to that in 2011?
Your answer should be compact. 1.02. What is the ratio of the Employment to population ratio(%) in High income in 2009 to that in 2012?
Your answer should be compact. 1. What is the ratio of the Employment to population ratio(%) in Somalia in 2009 to that in 2012?
Keep it short and to the point. 0.99. What is the ratio of the Employment to population ratio(%) in Spain in 2009 to that in 2012?
Provide a succinct answer. 1.05. What is the ratio of the Employment to population ratio(%) in Arab World in 2010 to that in 2011?
Offer a terse response. 1.01. What is the ratio of the Employment to population ratio(%) of High income in 2010 to that in 2011?
Provide a succinct answer. 1. What is the ratio of the Employment to population ratio(%) of Spain in 2010 to that in 2011?
Give a very brief answer. 1.01. What is the ratio of the Employment to population ratio(%) of Arab World in 2010 to that in 2012?
Your answer should be compact. 1. What is the ratio of the Employment to population ratio(%) in Spain in 2010 to that in 2012?
Make the answer very short. 1.04. What is the ratio of the Employment to population ratio(%) of High income in 2011 to that in 2012?
Your answer should be very brief. 1. What is the ratio of the Employment to population ratio(%) in Somalia in 2011 to that in 2012?
Give a very brief answer. 1. What is the ratio of the Employment to population ratio(%) of Spain in 2011 to that in 2012?
Provide a short and direct response. 1.03. What is the difference between the highest and the second highest Employment to population ratio(%) of Arab World?
Provide a short and direct response. 0.01. What is the difference between the highest and the second highest Employment to population ratio(%) of High income?
Provide a succinct answer. 0.14. What is the difference between the highest and the second highest Employment to population ratio(%) in Spain?
Offer a terse response. 0.1. What is the difference between the highest and the lowest Employment to population ratio(%) of Arab World?
Provide a short and direct response. 1.43. What is the difference between the highest and the lowest Employment to population ratio(%) of High income?
Your answer should be very brief. 1.19. What is the difference between the highest and the lowest Employment to population ratio(%) in Spain?
Provide a succinct answer. 3.8. 